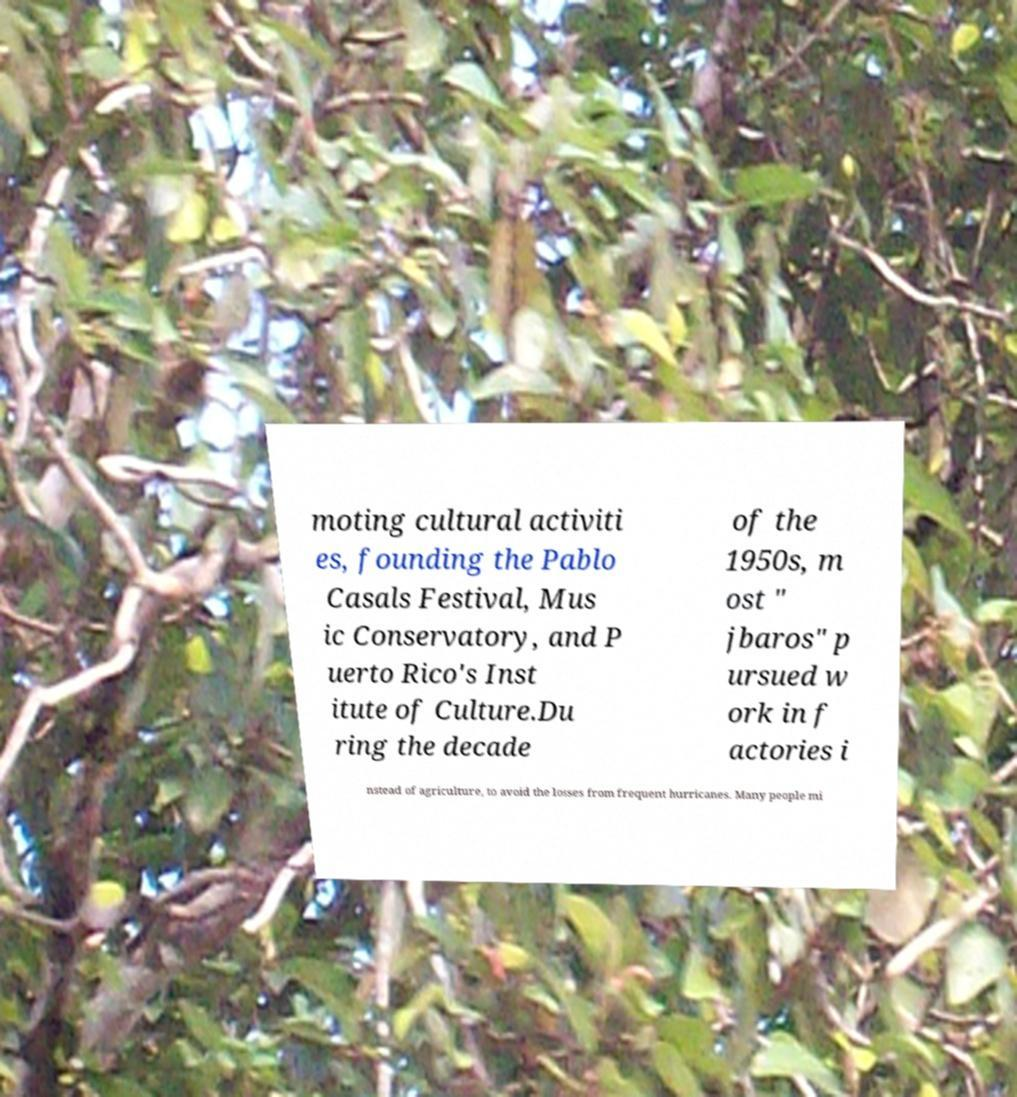Please read and relay the text visible in this image. What does it say? moting cultural activiti es, founding the Pablo Casals Festival, Mus ic Conservatory, and P uerto Rico's Inst itute of Culture.Du ring the decade of the 1950s, m ost " jbaros" p ursued w ork in f actories i nstead of agriculture, to avoid the losses from frequent hurricanes. Many people mi 